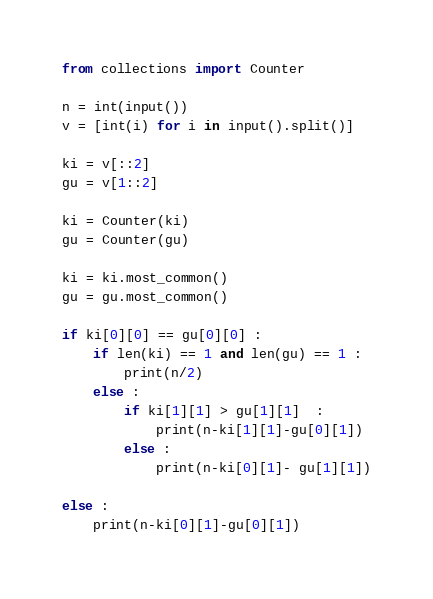Convert code to text. <code><loc_0><loc_0><loc_500><loc_500><_Python_>from collections import Counter

n = int(input())
v = [int(i) for i in input().split()]

ki = v[::2]
gu = v[1::2]

ki = Counter(ki)
gu = Counter(gu)

ki = ki.most_common()
gu = gu.most_common()

if ki[0][0] == gu[0][0] :
    if len(ki) == 1 and len(gu) == 1 :
        print(n/2)
    else :
        if ki[1][1] > gu[1][1]  :
            print(n-ki[1][1]-gu[0][1])
        else :
            print(n-ki[0][1]- gu[1][1])

else :
    print(n-ki[0][1]-gu[0][1])</code> 